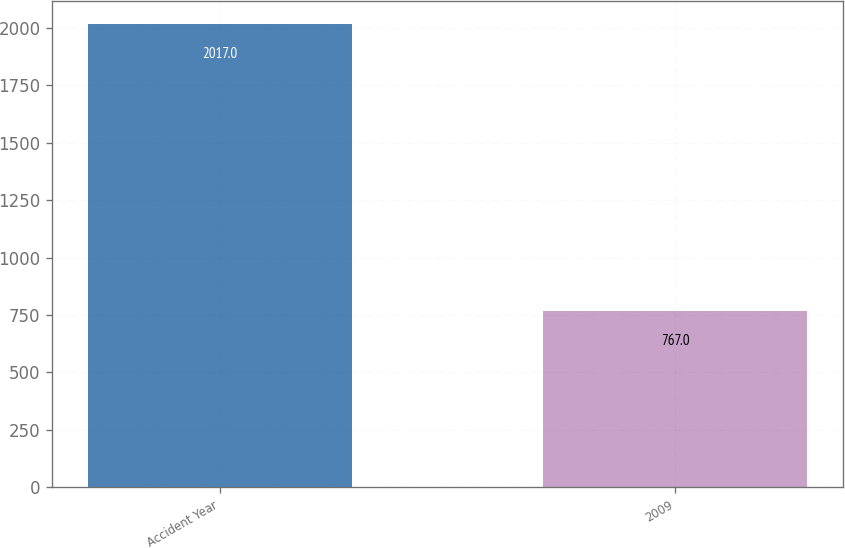<chart> <loc_0><loc_0><loc_500><loc_500><bar_chart><fcel>Accident Year<fcel>2009<nl><fcel>2017<fcel>767<nl></chart> 